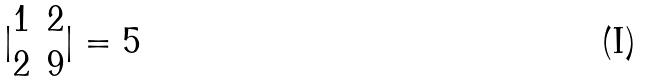<formula> <loc_0><loc_0><loc_500><loc_500>| \begin{matrix} 1 & 2 \\ 2 & 9 \\ \end{matrix} | = 5</formula> 